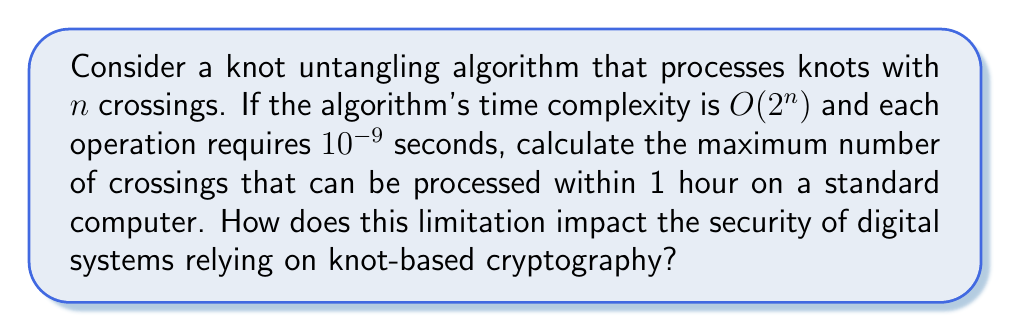Help me with this question. 1) First, we need to convert 1 hour to seconds:
   1 hour = 3600 seconds

2) The algorithm can process $2^n$ operations in the worst case for a knot with $n$ crossings.

3) Each operation takes $10^{-9}$ seconds. So, the total time $T$ for $n$ crossings is:
   $T = 2^n \times 10^{-9}$ seconds

4) We want to find the maximum $n$ such that $T \leq 3600$ seconds:
   $2^n \times 10^{-9} \leq 3600$

5) Solving for $n$:
   $2^n \leq 3600 \times 10^9$
   $2^n \leq 3.6 \times 10^{12}$

6) Taking $\log_2$ of both sides:
   $n \leq \log_2(3.6 \times 10^{12})$
   $n \leq 41.7$

7) Since $n$ must be an integer, the maximum value is 41.

8) Impact on security: This limitation means that knot-based cryptography systems using knots with more than 41 crossings would be computationally infeasible to break within an hour using this algorithm. This provides a baseline for the complexity required to ensure security against attacks using standard computational resources.
Answer: 41 crossings; ensures security for knots with >41 crossings 